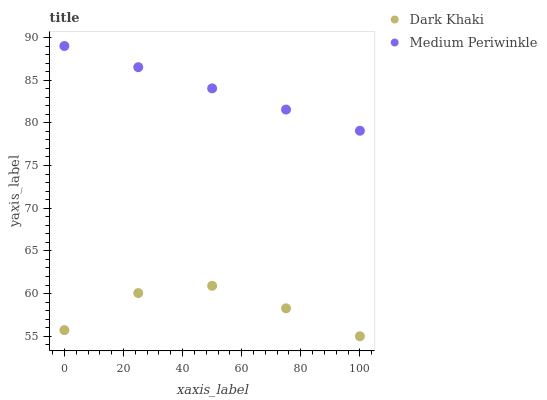Does Dark Khaki have the minimum area under the curve?
Answer yes or no. Yes. Does Medium Periwinkle have the maximum area under the curve?
Answer yes or no. Yes. Does Medium Periwinkle have the minimum area under the curve?
Answer yes or no. No. Is Medium Periwinkle the smoothest?
Answer yes or no. Yes. Is Dark Khaki the roughest?
Answer yes or no. Yes. Is Medium Periwinkle the roughest?
Answer yes or no. No. Does Dark Khaki have the lowest value?
Answer yes or no. Yes. Does Medium Periwinkle have the lowest value?
Answer yes or no. No. Does Medium Periwinkle have the highest value?
Answer yes or no. Yes. Is Dark Khaki less than Medium Periwinkle?
Answer yes or no. Yes. Is Medium Periwinkle greater than Dark Khaki?
Answer yes or no. Yes. Does Dark Khaki intersect Medium Periwinkle?
Answer yes or no. No. 